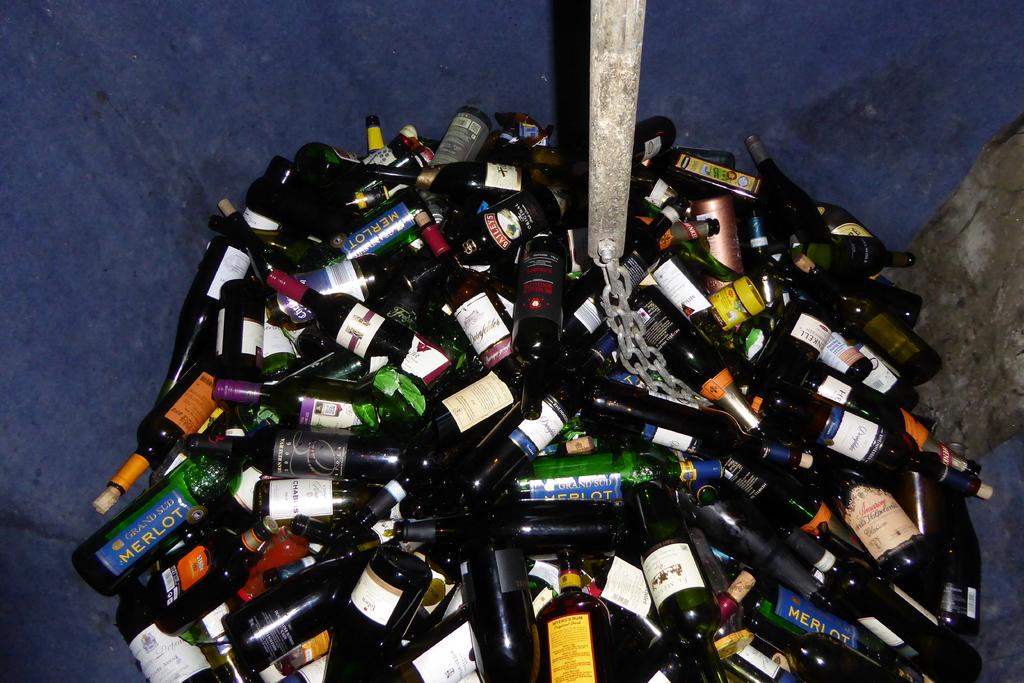What kind of wine in the green bottles?
Make the answer very short. Merlot. 